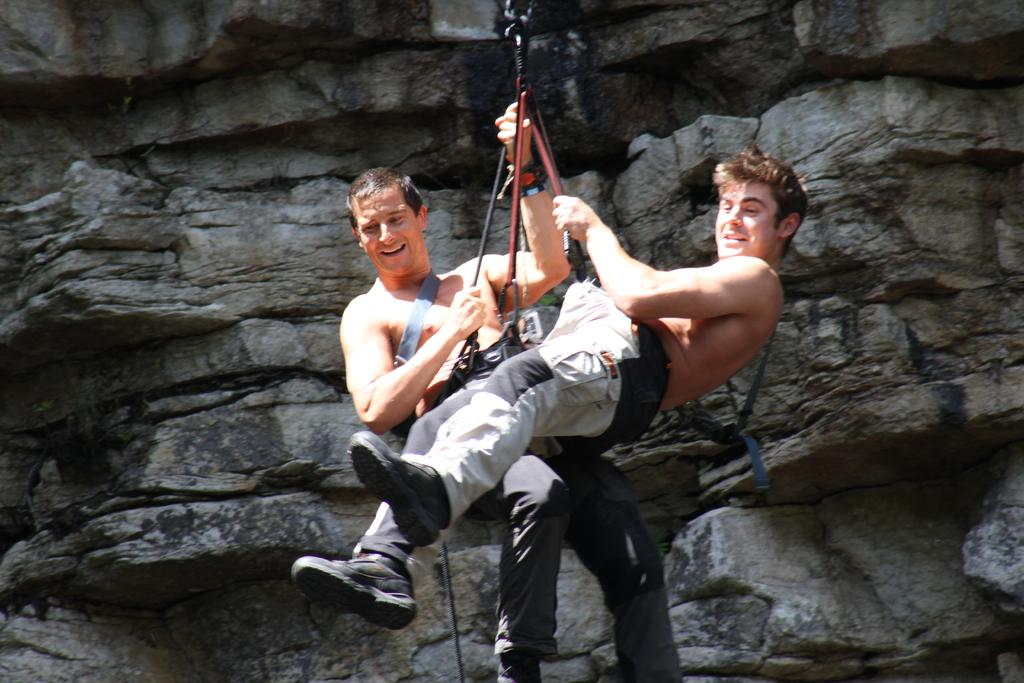What can be seen in the background of the image? There is a mountain in the background of the image. What activity are the men in the image engaged in? The men are performing an Abseiling in the image. How do the men appear to feel while performing the activity? The men are smiling, which suggests they are enjoying the activity. What type of flame can be seen on the mountain in the image? There is no flame present on the mountain in the image. How does the wave affect the men's Abseiling in the image? There is no wave present in the image, as it features a mountain and men performing Abseiling. 